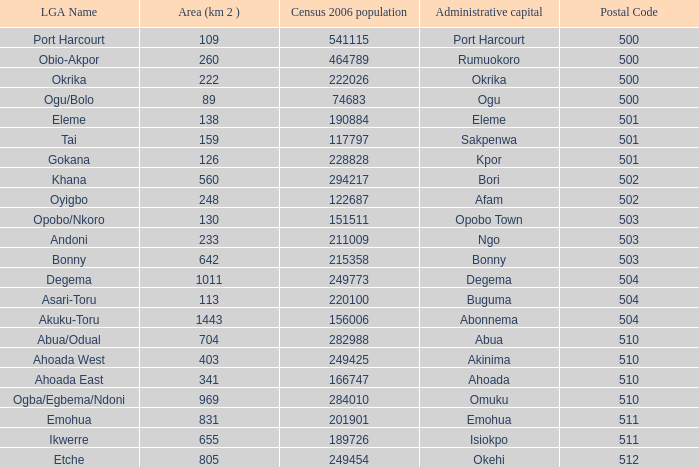What is the postal code when the administrative capital in Bori? 502.0. 